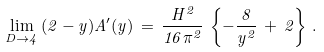Convert formula to latex. <formula><loc_0><loc_0><loc_500><loc_500>\lim _ { D \rightarrow 4 } \, ( 2 - y ) A ^ { \prime } ( y ) \, = \, \frac { H ^ { 2 } } { 1 6 \pi ^ { 2 } } \, \left \{ - \frac { 8 } { y ^ { 2 } } \, + \, 2 \right \} \, .</formula> 